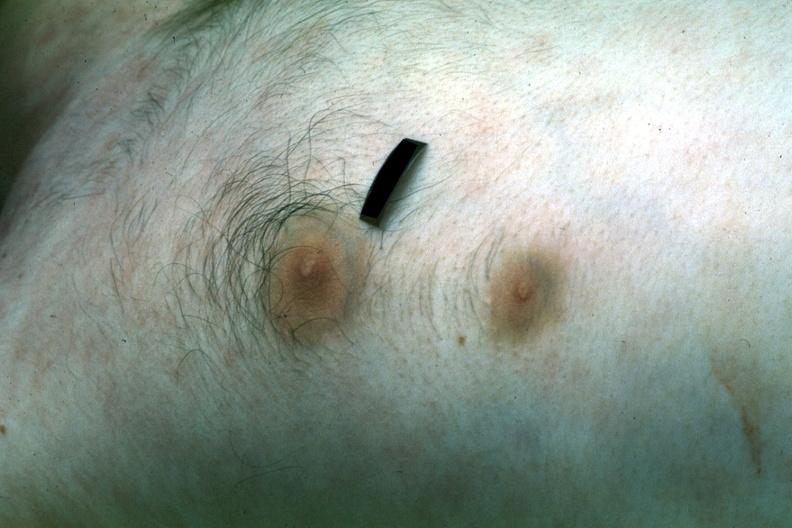s carcinoma present?
Answer the question using a single word or phrase. No 